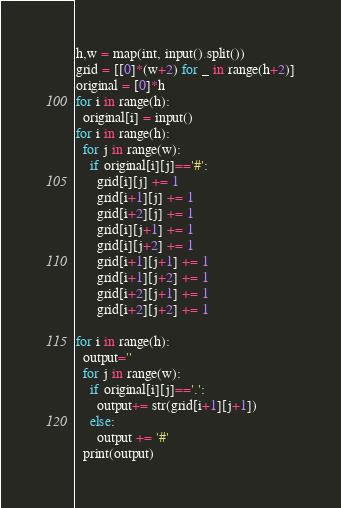<code> <loc_0><loc_0><loc_500><loc_500><_Python_>h,w = map(int, input().split())
grid = [[0]*(w+2) for _ in range(h+2)]
original = [0]*h
for i in range(h):
  original[i] = input()
for i in range(h):
  for j in range(w):
    if original[i][j]=='#':
      grid[i][j] += 1
      grid[i+1][j] += 1
      grid[i+2][j] += 1
      grid[i][j+1] += 1
      grid[i][j+2] += 1
      grid[i+1][j+1] += 1
      grid[i+1][j+2] += 1
      grid[i+2][j+1] += 1
      grid[i+2][j+2] += 1

for i in range(h):
  output=''
  for j in range(w):
    if original[i][j]=='.':
      output+= str(grid[i+1][j+1])
    else:
      output += '#'
  print(output)</code> 